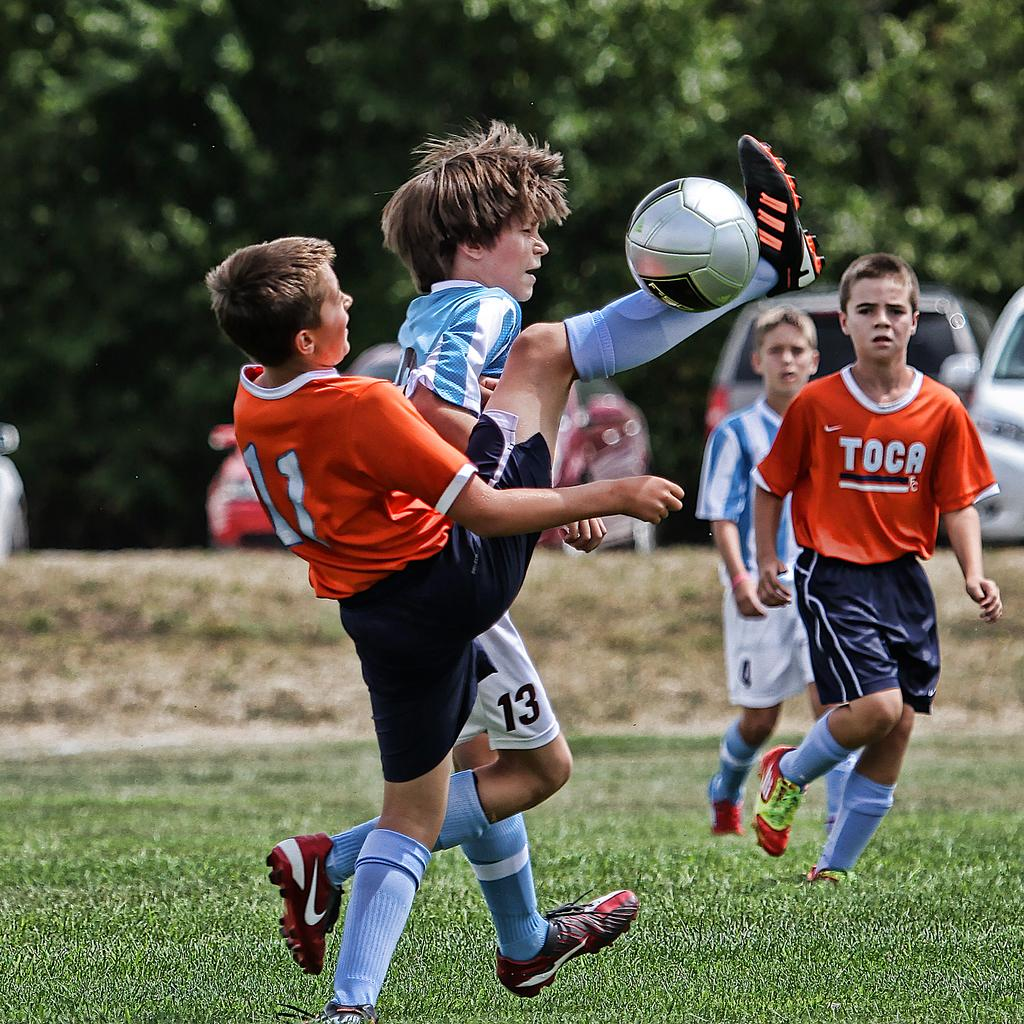What are the boys in the image doing? The boys are playing football. What can be seen in the background of the image? There are trees and vehicles parked in the background of the image. What type of medical advice is the doctor giving to the boys in the image? There is no doctor present in the image, so no medical advice can be given. 